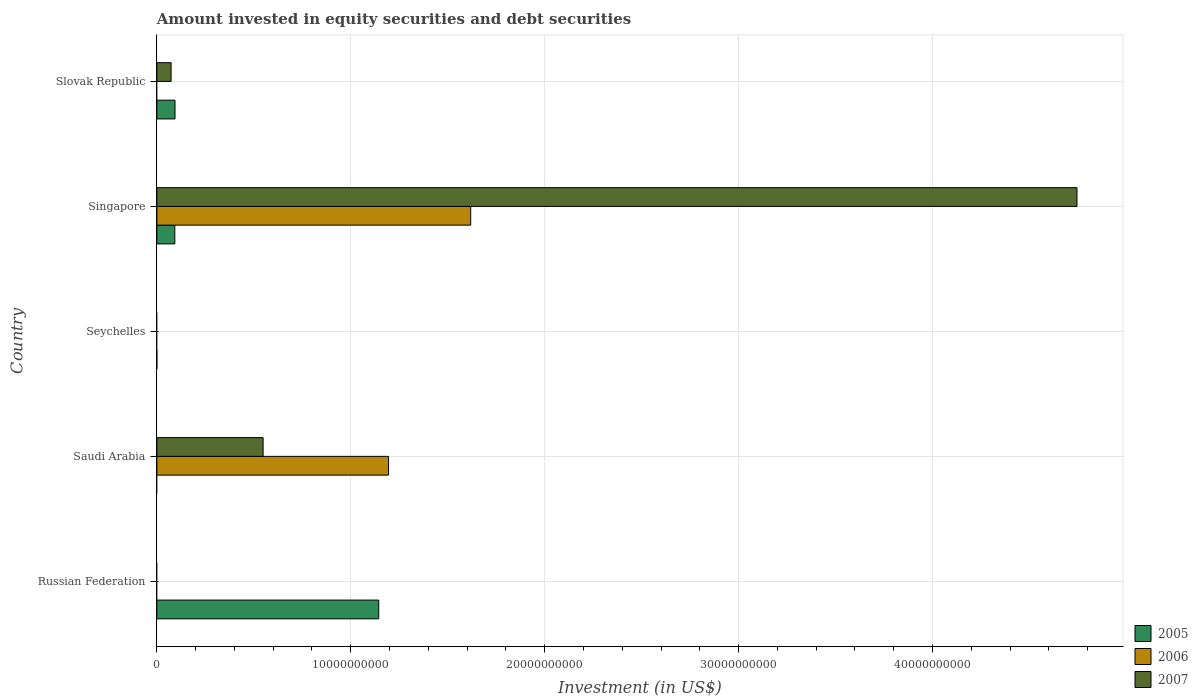Are the number of bars per tick equal to the number of legend labels?
Offer a very short reply. No. What is the label of the 4th group of bars from the top?
Your answer should be very brief. Saudi Arabia. Across all countries, what is the maximum amount invested in equity securities and debt securities in 2007?
Give a very brief answer. 4.74e+1. In which country was the amount invested in equity securities and debt securities in 2007 maximum?
Give a very brief answer. Singapore. What is the total amount invested in equity securities and debt securities in 2006 in the graph?
Your response must be concise. 2.81e+1. What is the difference between the amount invested in equity securities and debt securities in 2006 in Saudi Arabia and that in Singapore?
Your answer should be very brief. -4.24e+09. What is the difference between the amount invested in equity securities and debt securities in 2006 in Russian Federation and the amount invested in equity securities and debt securities in 2005 in Slovak Republic?
Your answer should be very brief. -9.37e+08. What is the average amount invested in equity securities and debt securities in 2005 per country?
Keep it short and to the point. 2.66e+09. What is the difference between the amount invested in equity securities and debt securities in 2007 and amount invested in equity securities and debt securities in 2005 in Singapore?
Your response must be concise. 4.65e+1. In how many countries, is the amount invested in equity securities and debt securities in 2006 greater than 38000000000 US$?
Offer a terse response. 0. What is the ratio of the amount invested in equity securities and debt securities in 2005 in Singapore to that in Slovak Republic?
Give a very brief answer. 0.99. Is the difference between the amount invested in equity securities and debt securities in 2007 in Singapore and Slovak Republic greater than the difference between the amount invested in equity securities and debt securities in 2005 in Singapore and Slovak Republic?
Your response must be concise. Yes. What is the difference between the highest and the second highest amount invested in equity securities and debt securities in 2007?
Offer a terse response. 4.20e+1. What is the difference between the highest and the lowest amount invested in equity securities and debt securities in 2006?
Offer a very short reply. 1.62e+1. How many bars are there?
Offer a very short reply. 8. Are all the bars in the graph horizontal?
Keep it short and to the point. Yes. What is the difference between two consecutive major ticks on the X-axis?
Give a very brief answer. 1.00e+1. Are the values on the major ticks of X-axis written in scientific E-notation?
Provide a short and direct response. No. Does the graph contain grids?
Offer a terse response. Yes. Where does the legend appear in the graph?
Offer a very short reply. Bottom right. How many legend labels are there?
Make the answer very short. 3. How are the legend labels stacked?
Provide a succinct answer. Vertical. What is the title of the graph?
Offer a very short reply. Amount invested in equity securities and debt securities. Does "1992" appear as one of the legend labels in the graph?
Offer a very short reply. No. What is the label or title of the X-axis?
Offer a terse response. Investment (in US$). What is the Investment (in US$) in 2005 in Russian Federation?
Offer a very short reply. 1.14e+1. What is the Investment (in US$) of 2006 in Russian Federation?
Provide a succinct answer. 0. What is the Investment (in US$) in 2005 in Saudi Arabia?
Ensure brevity in your answer.  0. What is the Investment (in US$) of 2006 in Saudi Arabia?
Give a very brief answer. 1.19e+1. What is the Investment (in US$) in 2007 in Saudi Arabia?
Your response must be concise. 5.48e+09. What is the Investment (in US$) in 2005 in Seychelles?
Keep it short and to the point. 0. What is the Investment (in US$) of 2005 in Singapore?
Offer a terse response. 9.27e+08. What is the Investment (in US$) of 2006 in Singapore?
Your answer should be very brief. 1.62e+1. What is the Investment (in US$) in 2007 in Singapore?
Offer a very short reply. 4.74e+1. What is the Investment (in US$) in 2005 in Slovak Republic?
Your response must be concise. 9.37e+08. What is the Investment (in US$) of 2006 in Slovak Republic?
Your response must be concise. 0. What is the Investment (in US$) of 2007 in Slovak Republic?
Provide a succinct answer. 7.34e+08. Across all countries, what is the maximum Investment (in US$) in 2005?
Your answer should be very brief. 1.14e+1. Across all countries, what is the maximum Investment (in US$) of 2006?
Your answer should be very brief. 1.62e+1. Across all countries, what is the maximum Investment (in US$) of 2007?
Make the answer very short. 4.74e+1. Across all countries, what is the minimum Investment (in US$) in 2006?
Your response must be concise. 0. What is the total Investment (in US$) in 2005 in the graph?
Your answer should be very brief. 1.33e+1. What is the total Investment (in US$) of 2006 in the graph?
Ensure brevity in your answer.  2.81e+1. What is the total Investment (in US$) of 2007 in the graph?
Provide a short and direct response. 5.37e+1. What is the difference between the Investment (in US$) in 2005 in Russian Federation and that in Singapore?
Provide a short and direct response. 1.05e+1. What is the difference between the Investment (in US$) of 2005 in Russian Federation and that in Slovak Republic?
Provide a succinct answer. 1.05e+1. What is the difference between the Investment (in US$) in 2006 in Saudi Arabia and that in Singapore?
Keep it short and to the point. -4.24e+09. What is the difference between the Investment (in US$) in 2007 in Saudi Arabia and that in Singapore?
Provide a succinct answer. -4.20e+1. What is the difference between the Investment (in US$) in 2007 in Saudi Arabia and that in Slovak Republic?
Provide a short and direct response. 4.75e+09. What is the difference between the Investment (in US$) in 2005 in Singapore and that in Slovak Republic?
Your answer should be very brief. -9.90e+06. What is the difference between the Investment (in US$) in 2007 in Singapore and that in Slovak Republic?
Offer a very short reply. 4.67e+1. What is the difference between the Investment (in US$) in 2005 in Russian Federation and the Investment (in US$) in 2006 in Saudi Arabia?
Provide a succinct answer. -5.06e+08. What is the difference between the Investment (in US$) of 2005 in Russian Federation and the Investment (in US$) of 2007 in Saudi Arabia?
Provide a succinct answer. 5.96e+09. What is the difference between the Investment (in US$) in 2005 in Russian Federation and the Investment (in US$) in 2006 in Singapore?
Your response must be concise. -4.74e+09. What is the difference between the Investment (in US$) of 2005 in Russian Federation and the Investment (in US$) of 2007 in Singapore?
Give a very brief answer. -3.60e+1. What is the difference between the Investment (in US$) of 2005 in Russian Federation and the Investment (in US$) of 2007 in Slovak Republic?
Give a very brief answer. 1.07e+1. What is the difference between the Investment (in US$) in 2006 in Saudi Arabia and the Investment (in US$) in 2007 in Singapore?
Ensure brevity in your answer.  -3.55e+1. What is the difference between the Investment (in US$) in 2006 in Saudi Arabia and the Investment (in US$) in 2007 in Slovak Republic?
Offer a terse response. 1.12e+1. What is the difference between the Investment (in US$) of 2005 in Singapore and the Investment (in US$) of 2007 in Slovak Republic?
Your answer should be compact. 1.92e+08. What is the difference between the Investment (in US$) of 2006 in Singapore and the Investment (in US$) of 2007 in Slovak Republic?
Your response must be concise. 1.55e+1. What is the average Investment (in US$) in 2005 per country?
Your answer should be compact. 2.66e+09. What is the average Investment (in US$) of 2006 per country?
Your response must be concise. 5.63e+09. What is the average Investment (in US$) of 2007 per country?
Your response must be concise. 1.07e+1. What is the difference between the Investment (in US$) of 2006 and Investment (in US$) of 2007 in Saudi Arabia?
Offer a terse response. 6.47e+09. What is the difference between the Investment (in US$) of 2005 and Investment (in US$) of 2006 in Singapore?
Provide a short and direct response. -1.53e+1. What is the difference between the Investment (in US$) in 2005 and Investment (in US$) in 2007 in Singapore?
Keep it short and to the point. -4.65e+1. What is the difference between the Investment (in US$) in 2006 and Investment (in US$) in 2007 in Singapore?
Your answer should be very brief. -3.13e+1. What is the difference between the Investment (in US$) of 2005 and Investment (in US$) of 2007 in Slovak Republic?
Give a very brief answer. 2.02e+08. What is the ratio of the Investment (in US$) of 2005 in Russian Federation to that in Singapore?
Provide a short and direct response. 12.35. What is the ratio of the Investment (in US$) in 2005 in Russian Federation to that in Slovak Republic?
Your answer should be very brief. 12.22. What is the ratio of the Investment (in US$) in 2006 in Saudi Arabia to that in Singapore?
Give a very brief answer. 0.74. What is the ratio of the Investment (in US$) of 2007 in Saudi Arabia to that in Singapore?
Your answer should be compact. 0.12. What is the ratio of the Investment (in US$) in 2007 in Saudi Arabia to that in Slovak Republic?
Offer a very short reply. 7.46. What is the ratio of the Investment (in US$) in 2005 in Singapore to that in Slovak Republic?
Give a very brief answer. 0.99. What is the ratio of the Investment (in US$) of 2007 in Singapore to that in Slovak Republic?
Keep it short and to the point. 64.62. What is the difference between the highest and the second highest Investment (in US$) of 2005?
Your answer should be very brief. 1.05e+1. What is the difference between the highest and the second highest Investment (in US$) in 2007?
Keep it short and to the point. 4.20e+1. What is the difference between the highest and the lowest Investment (in US$) in 2005?
Provide a short and direct response. 1.14e+1. What is the difference between the highest and the lowest Investment (in US$) of 2006?
Your answer should be very brief. 1.62e+1. What is the difference between the highest and the lowest Investment (in US$) in 2007?
Ensure brevity in your answer.  4.74e+1. 